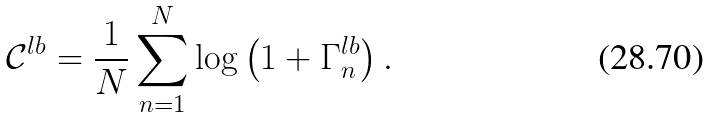<formula> <loc_0><loc_0><loc_500><loc_500>\mathcal { C } ^ { l b } = \frac { 1 } { N } \sum _ { n = 1 } ^ { N } \log \left ( 1 + \Gamma _ { n } ^ { l b } \right ) .</formula> 